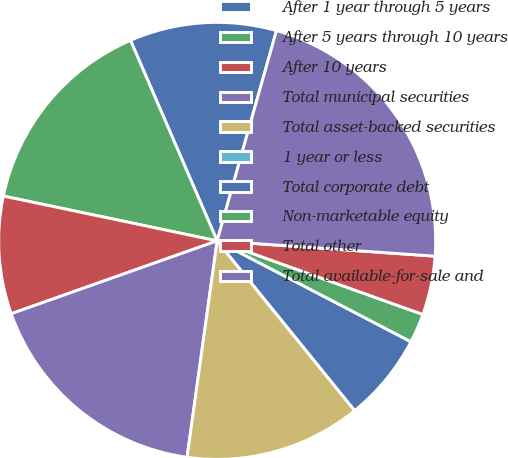Convert chart to OTSL. <chart><loc_0><loc_0><loc_500><loc_500><pie_chart><fcel>After 1 year through 5 years<fcel>After 5 years through 10 years<fcel>After 10 years<fcel>Total municipal securities<fcel>Total asset-backed securities<fcel>1 year or less<fcel>Total corporate debt<fcel>Non-marketable equity<fcel>Total other<fcel>Total available-for-sale and<nl><fcel>10.87%<fcel>15.22%<fcel>8.7%<fcel>17.39%<fcel>13.04%<fcel>0.0%<fcel>6.52%<fcel>2.17%<fcel>4.35%<fcel>21.74%<nl></chart> 